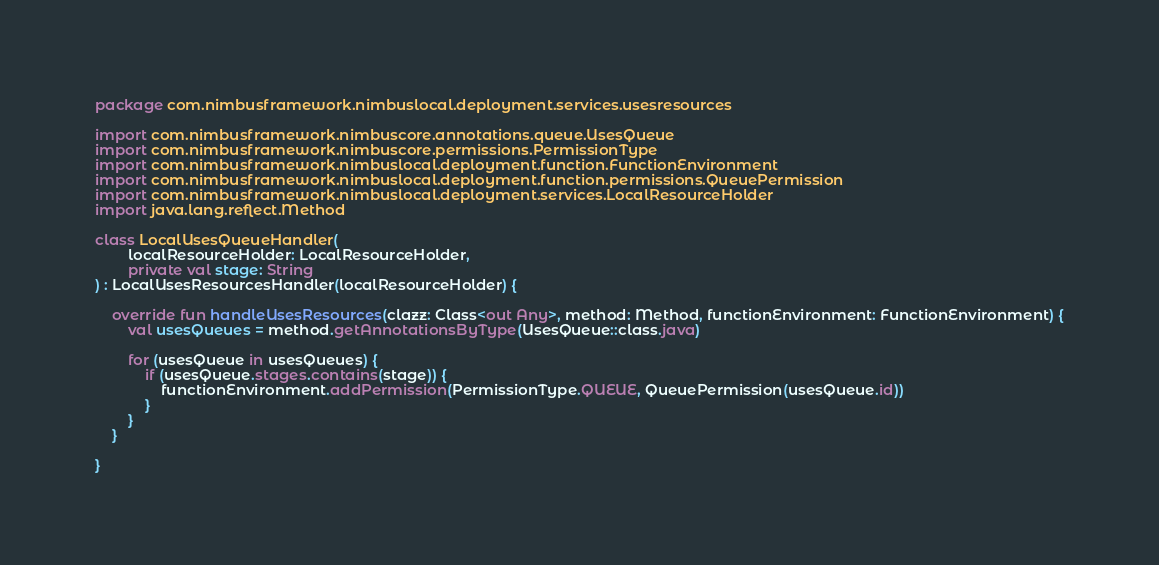<code> <loc_0><loc_0><loc_500><loc_500><_Kotlin_>package com.nimbusframework.nimbuslocal.deployment.services.usesresources

import com.nimbusframework.nimbuscore.annotations.queue.UsesQueue
import com.nimbusframework.nimbuscore.permissions.PermissionType
import com.nimbusframework.nimbuslocal.deployment.function.FunctionEnvironment
import com.nimbusframework.nimbuslocal.deployment.function.permissions.QueuePermission
import com.nimbusframework.nimbuslocal.deployment.services.LocalResourceHolder
import java.lang.reflect.Method

class LocalUsesQueueHandler(
        localResourceHolder: LocalResourceHolder,
        private val stage: String
) : LocalUsesResourcesHandler(localResourceHolder) {

    override fun handleUsesResources(clazz: Class<out Any>, method: Method, functionEnvironment: FunctionEnvironment) {
        val usesQueues = method.getAnnotationsByType(UsesQueue::class.java)

        for (usesQueue in usesQueues) {
            if (usesQueue.stages.contains(stage)) {
                functionEnvironment.addPermission(PermissionType.QUEUE, QueuePermission(usesQueue.id))
            }
        }
    }

}</code> 